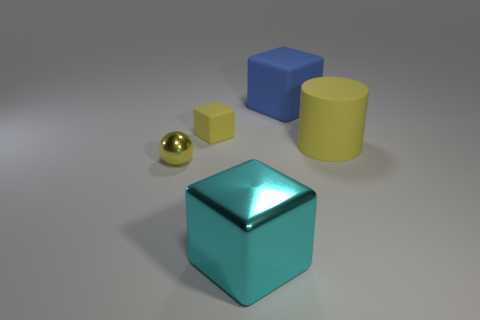What is the material of the blue cube?
Your response must be concise. Rubber. Is the number of tiny things left of the small yellow rubber cube greater than the number of tiny blue rubber cylinders?
Keep it short and to the point. Yes. What number of large metal blocks are on the right side of the rubber block that is on the right side of the metal thing that is in front of the small metal sphere?
Your answer should be very brief. 0. There is a block that is both behind the large yellow cylinder and in front of the big blue object; what is it made of?
Make the answer very short. Rubber. The sphere has what color?
Provide a short and direct response. Yellow. Are there more cyan shiny things in front of the yellow matte cylinder than cyan metallic blocks in front of the cyan object?
Ensure brevity in your answer.  Yes. There is a metal object that is behind the big cyan cube; what is its color?
Offer a terse response. Yellow. Is the size of the metallic thing that is in front of the tiny sphere the same as the yellow matte thing that is to the right of the yellow matte block?
Give a very brief answer. Yes. How many objects are small gray metal cylinders or blue rubber blocks?
Ensure brevity in your answer.  1. There is a small yellow thing that is to the right of the tiny sphere in front of the big blue block; what is it made of?
Offer a terse response. Rubber. 